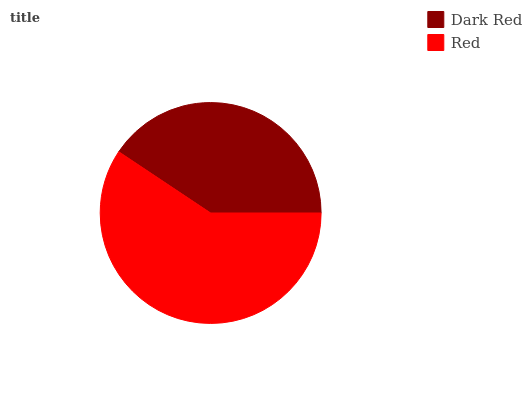Is Dark Red the minimum?
Answer yes or no. Yes. Is Red the maximum?
Answer yes or no. Yes. Is Red the minimum?
Answer yes or no. No. Is Red greater than Dark Red?
Answer yes or no. Yes. Is Dark Red less than Red?
Answer yes or no. Yes. Is Dark Red greater than Red?
Answer yes or no. No. Is Red less than Dark Red?
Answer yes or no. No. Is Red the high median?
Answer yes or no. Yes. Is Dark Red the low median?
Answer yes or no. Yes. Is Dark Red the high median?
Answer yes or no. No. Is Red the low median?
Answer yes or no. No. 